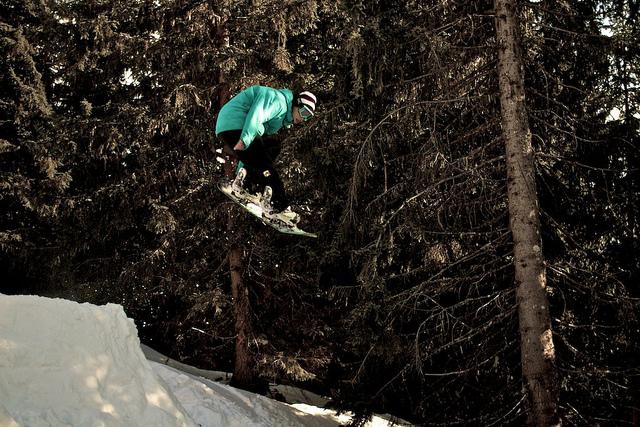What sport is this?
Keep it brief. Snowboarding. Is it sunny?
Give a very brief answer. Yes. What color coat are they wearing?
Answer briefly. Green. 